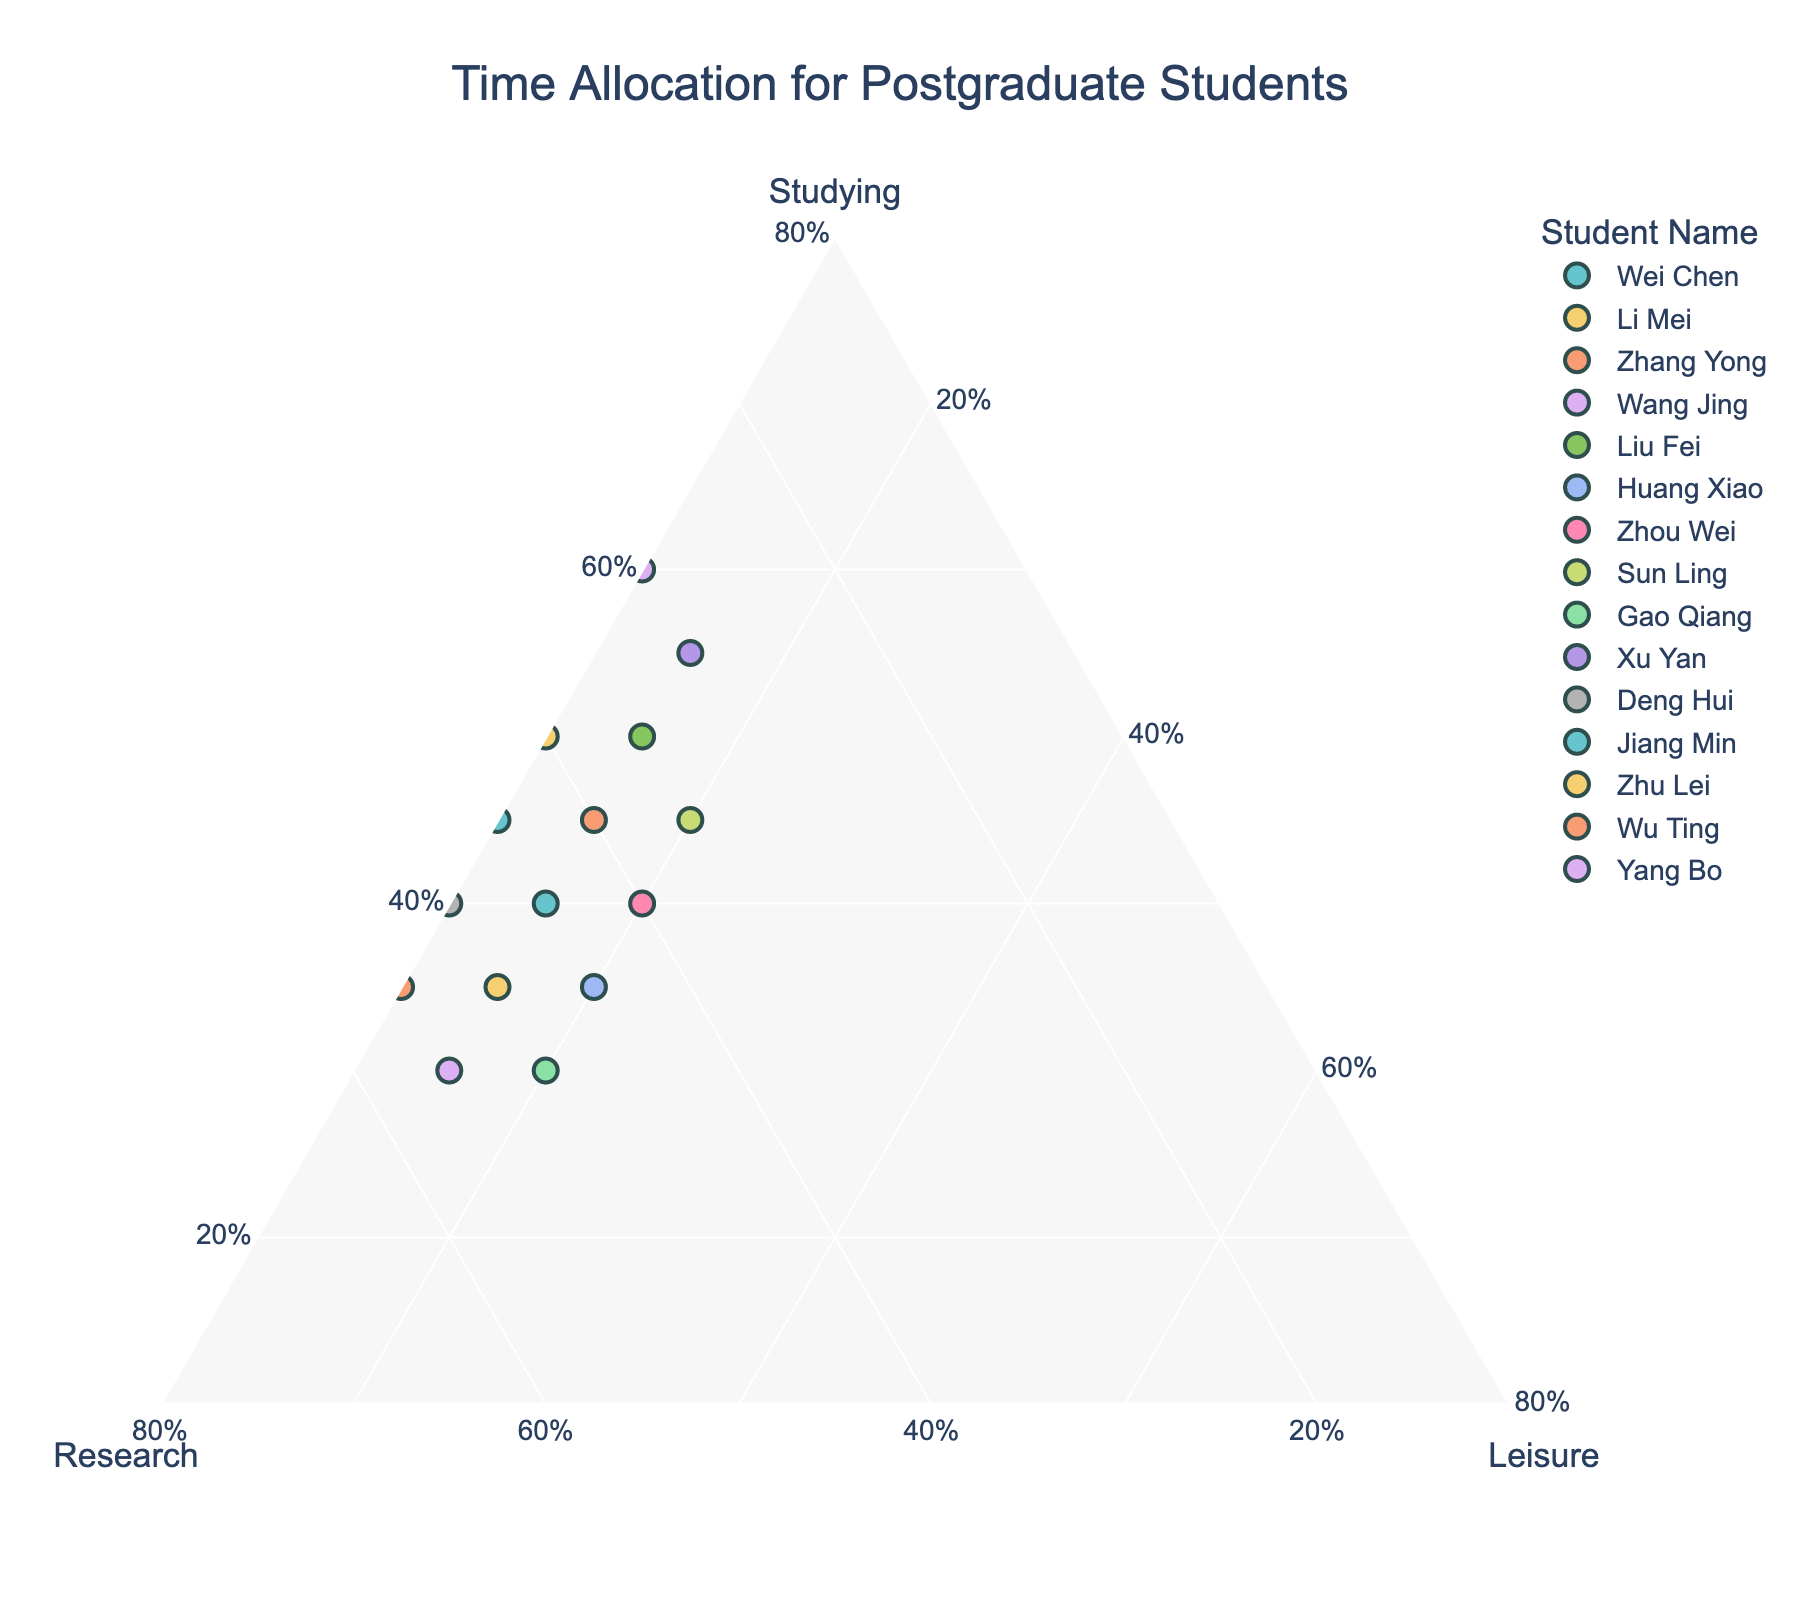What's the title of the plot? The title is typically displayed prominently at the top of the chart. By reviewing the description, we know it is related to "Time Allocation for Postgraduate Students".
Answer: Time Allocation for Postgraduate Students How many students allocate more time to studying than to research? By examining each data point, we can compare the studying and research values. The students who spend more time studying are Wei Chen, Zhang Yong, Liu Fei, Xu Yan, Deng Hui, Jiang Min, Zhu Lei, and Yang Bo.
Answer: 8 Which student spends the least time on leisure activities? By finding the data points with the minimum value in the 'Leisure' axis, we see that Deng Hui, Jiang Min, Zhu Lei, Wu Ting, and Yang Bo spend 10% of their time on leisure, which is the least.
Answer: Deng Hui, Jiang Min, Zhu Lei, Wu Ting, Yang Bo How many students spend exactly 45% of their time on research? Check each data point to identify which students' research percentage is 45%. They are Wei Chen, Huang Xiao, and Jiang Min.
Answer: 3 Between Li Mei and Gao Qiang, who spends more time on research? By comparing the research percentages, we see that Gao Qiang spends 50% while Li Mei also spends 50%.
Answer: Both Who is the student that spends the most time on studying? By analyzing each data point, Xu Yan spends 55% of their time on studying.
Answer: Xu Yan What's the average percentage of time spent on leisure activities for all students? Sum the leisure percentages for all students and divide by the number of students: (15+15+15+15+15+20+20+20+20+15+10+10+10+10+10)/15 = 190/15 = 12.67%.
Answer: 12.67% Which students have an equal allocation of time to studying and research? Check the data for students whose studying and research percentages are the same. Wei Chen, Zhang Yong, Zhou Wei, and Jiang Min have equal allocations.
Answer: Wei Chen, Zhang Yong, Zhou Wei, Jiang Min What's the total percentage of time spent on research by all students? Sum the research percentages of all students: 45+50+40+55+35+45+40+35+50+30+50+45+40+55+30 = 595.
Answer: 595 Between Liu Fei and Sun Ling, who spends more time on leisure activities? By comparing leisure percentages, Sun Ling spends 20% while Liu Fei spends 15%.
Answer: Sun Ling 